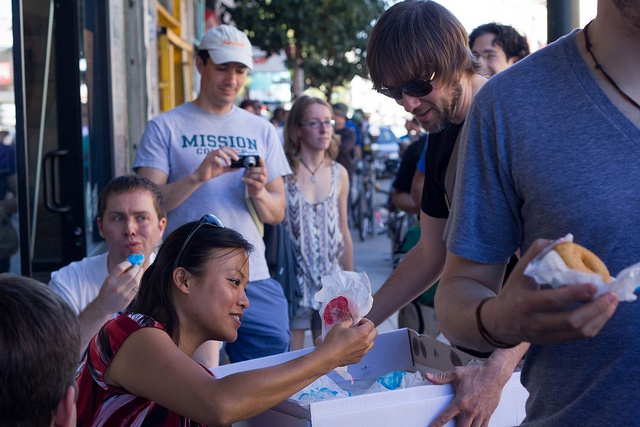Describe the objects in this image and their specific colors. I can see people in white, navy, black, gray, and darkblue tones, people in white, black, maroon, and brown tones, people in white, darkgray, blue, gray, and lavender tones, people in white, black, gray, and purple tones, and people in white, darkgray, gray, and navy tones in this image. 